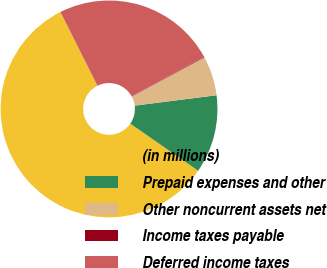Convert chart. <chart><loc_0><loc_0><loc_500><loc_500><pie_chart><fcel>(in millions)<fcel>Prepaid expenses and other<fcel>Other noncurrent assets net<fcel>Income taxes payable<fcel>Deferred income taxes<nl><fcel>57.95%<fcel>11.67%<fcel>5.88%<fcel>0.1%<fcel>24.4%<nl></chart> 